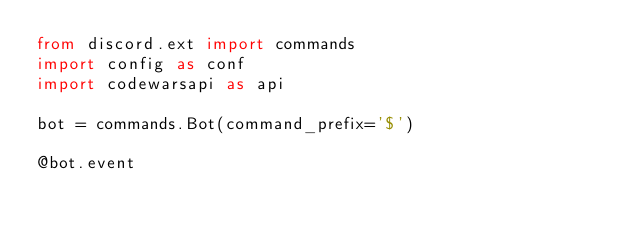Convert code to text. <code><loc_0><loc_0><loc_500><loc_500><_Python_>from discord.ext import commands
import config as conf
import codewarsapi as api

bot = commands.Bot(command_prefix='$')

@bot.event</code> 